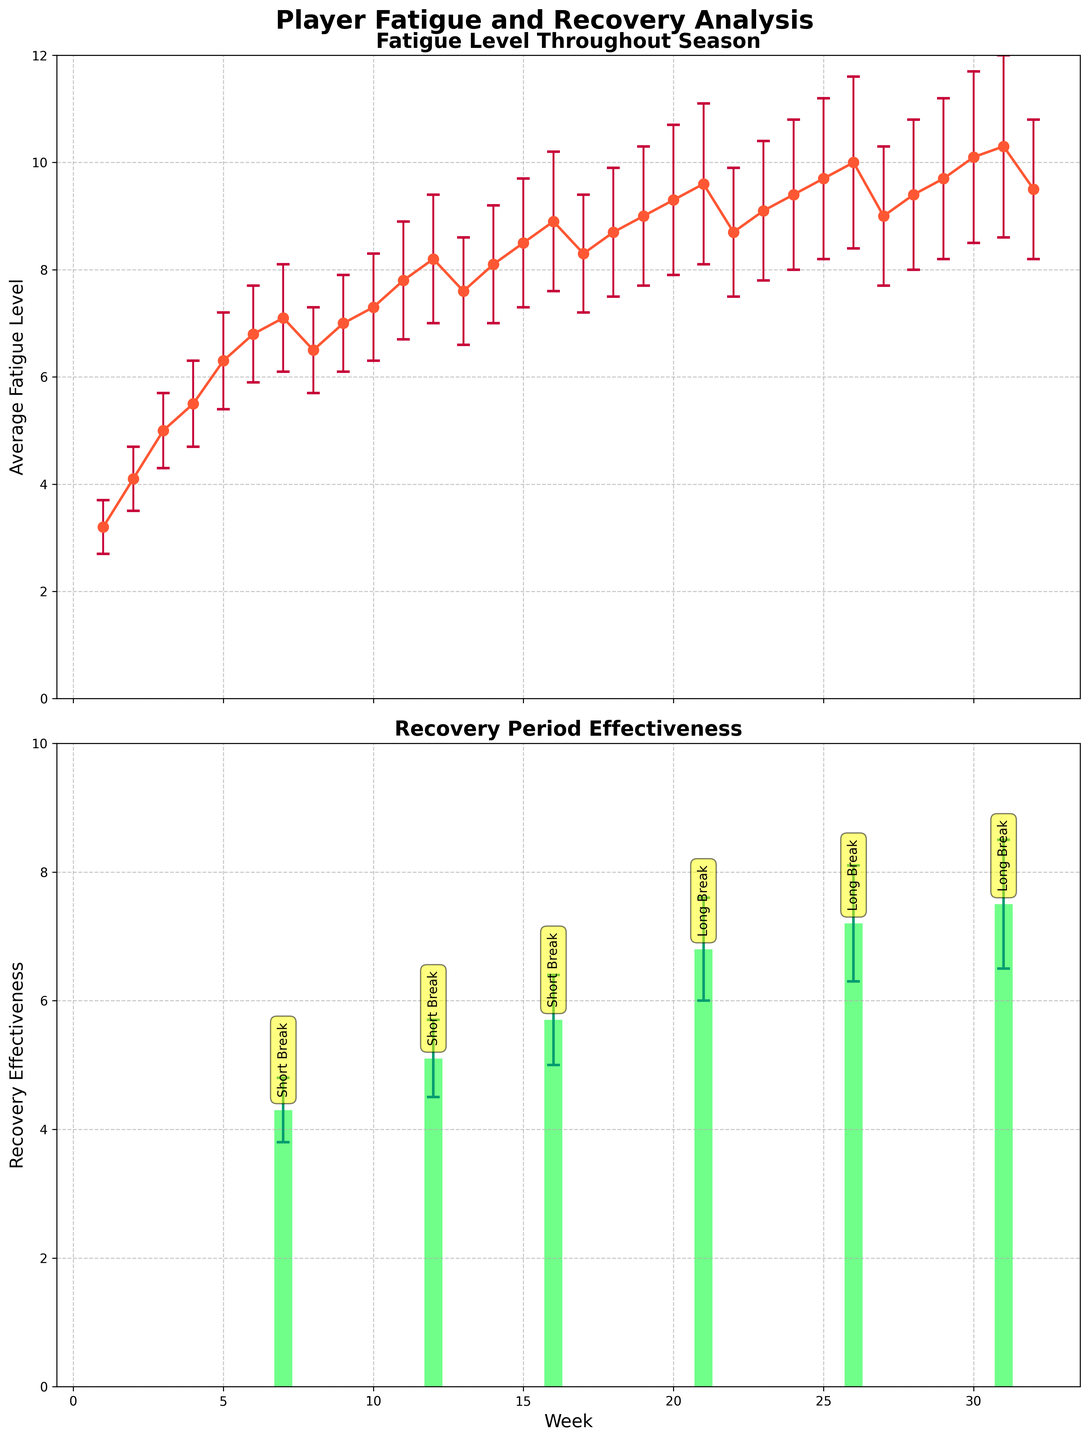What is the title of the top subplot? The title of the top subplot is written at the top of the subplot.
Answer: Fatigue Level Throughout Season At which week did the player take the first Short Break? Check the annotations and the x-axis labels in the second subplot for the "Short Break" label.
Answer: Week 7 What is the average fatigue level at Week 14? Locate Week 14 on the x-axis of the first subplot and read the corresponding fatigue level value.
Answer: 8.1 Compare the average fatigue levels between Week 10 and Week 20. Which is higher? Find Week 10 and Week 20 on the x-axis of the first subplot, then compare the average fatigue levels for these weeks.
Answer: Week 20 is higher What is the difference in recovery effectiveness between the Short Break at Week 12 and the Long Break at Week 26? Identify the recovery effectiveness at Week 12 and Week 26 in the second subplot, then compute the difference.
Answer: 7.2 - 5.1 = 2.1 How many recovery periods are there throughout the season? Count the number of unique annotated recovery periods in the second subplot.
Answer: 5 What is the highest average fatigue level observed, and in which week does it occur? Look for the peak point in the first subplot's average fatigue level line and note the corresponding week.
Answer: 10.3, Week 31 Which recovery period has the highest average effectiveness and what is its value? Check the bars in the second subplot and identify the tallest one, noting its value.
Answer: Long Break, 7.5 What is the trend in fatigue levels before and after the Long Break at Week 21? Examine the line movement in the first subplot before and after Week 21 to describe the trend.
Answer: Increasing before and decreasing after 